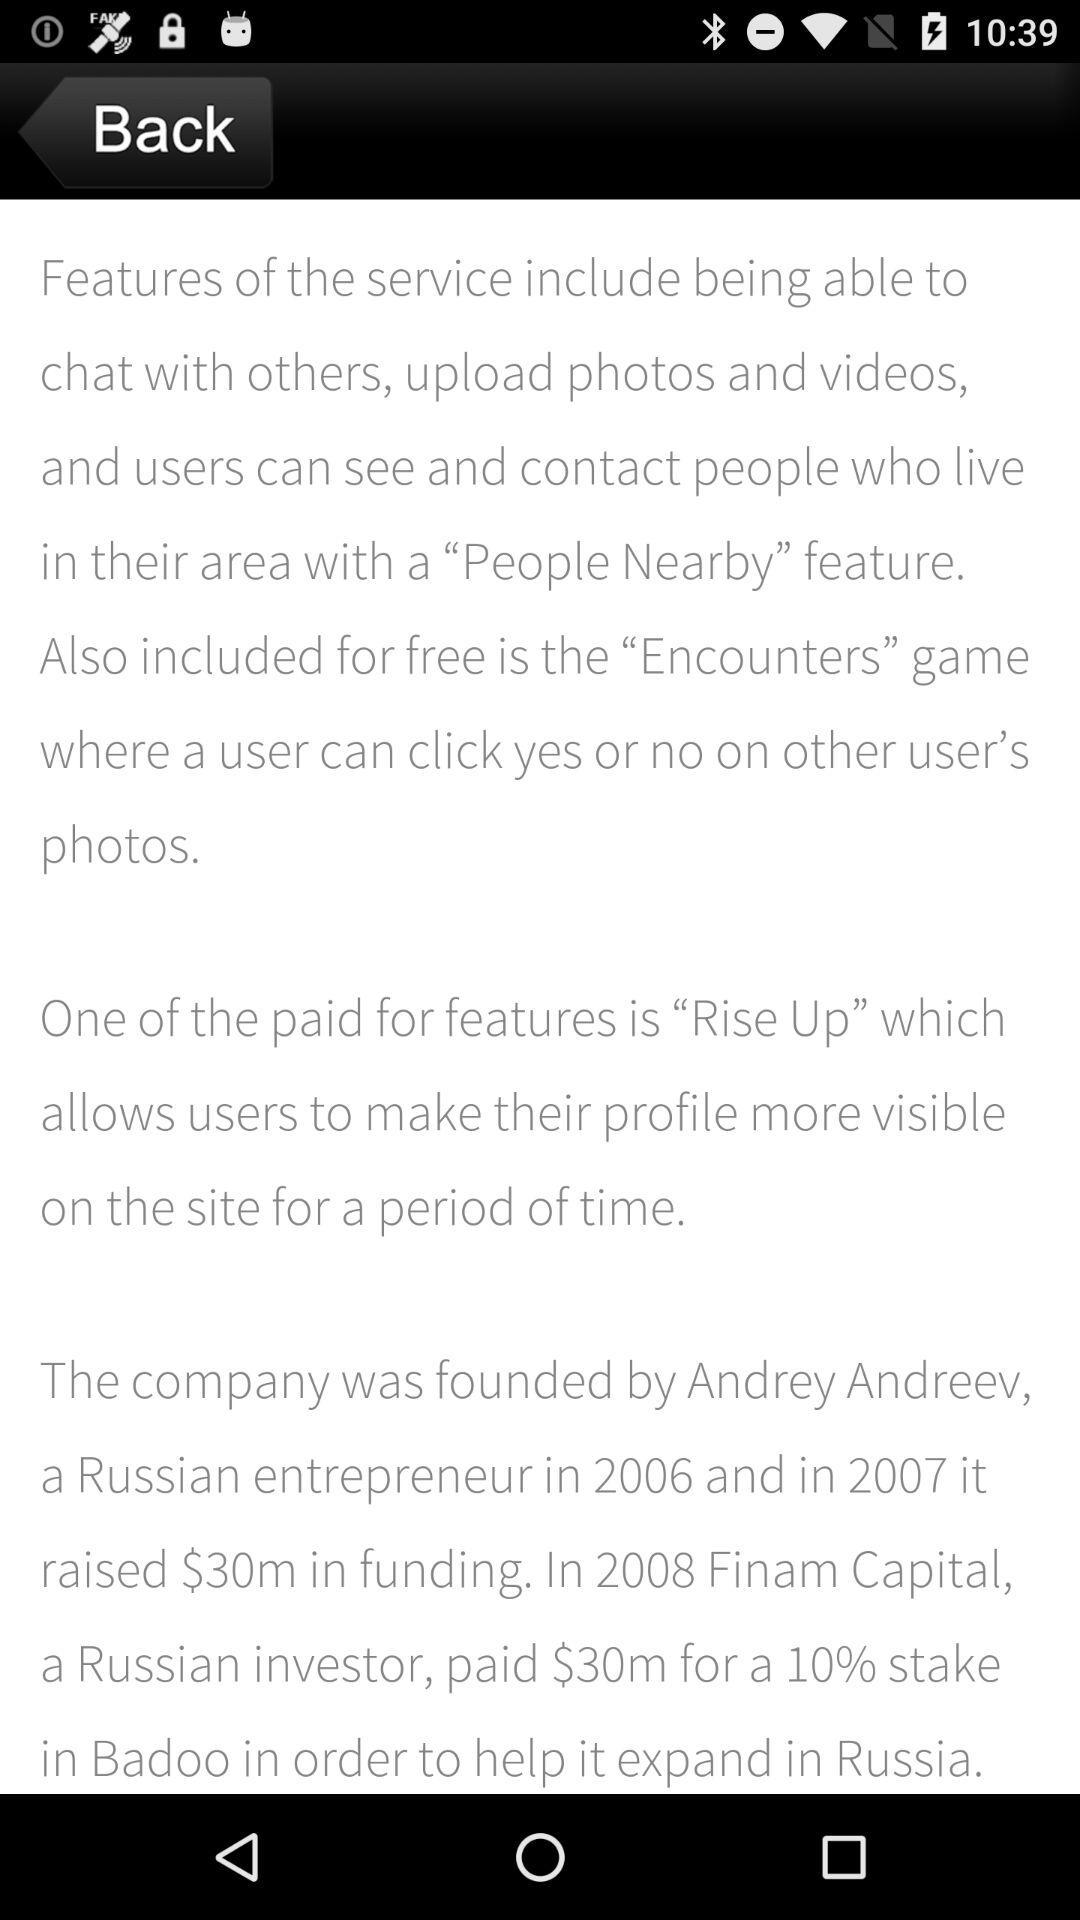How much money did Badoo raise in 2007?
Answer the question using a single word or phrase. $30m 